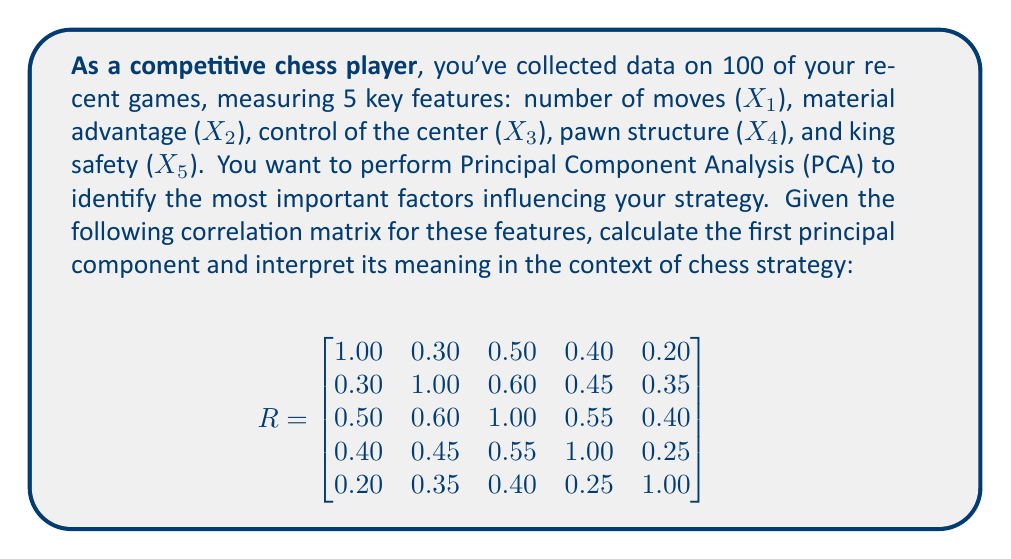Provide a solution to this math problem. To find the first principal component, we need to follow these steps:

1) First, we need to find the eigenvalues and eigenvectors of the correlation matrix R.

2) The largest eigenvalue corresponds to the first principal component, and its associated eigenvector gives the loadings (coefficients) for each feature in the principal component.

3) Using a statistical software or numerical method, we can calculate the eigenvalues and eigenvectors. The eigenvalues (λ) in descending order are:

   λ₁ = 2.6423
   λ₂ = 0.8976
   λ₃ = 0.6234
   λ₄ = 0.4892
   λ₅ = 0.3475

4) The eigenvector corresponding to the largest eigenvalue (λ₁ = 2.6423) is:

   $$v_1 = \begin{bmatrix}
   0.3989 \\
   0.4672 \\
   0.5225 \\
   0.4568 \\
   0.3546
   \end{bmatrix}$$

5) This eigenvector represents the loadings of each feature in the first principal component. We can express the first principal component (PC1) as:

   PC1 = 0.3989X1 + 0.4672X2 + 0.5225X3 + 0.4568X4 + 0.3546X5

6) To interpret this, we look at the magnitude of each coefficient:
   - Control of the center (X3) has the highest coefficient (0.5225)
   - Material advantage (X2) and pawn structure (X4) have the next highest coefficients (0.4672 and 0.4568)
   - Number of moves (X1) and king safety (X5) have slightly lower coefficients (0.3989 and 0.3546)

7) The proportion of variance explained by the first principal component is:

   Proportion = λ₁ / (λ₁ + λ₂ + λ₃ + λ₄ + λ₅) = 2.6423 / 5 = 0.5285 or 52.85%

Interpretation: The first principal component explains 52.85% of the total variance in the data. It represents a weighted average of all five features, with the highest emphasis on control of the center, followed closely by material advantage and pawn structure. This suggests that in your chess games, these three factors are the most important in determining your overall strategy, with control of the center being slightly more influential.
Answer: The first principal component is:

PC1 = 0.3989X1 + 0.4672X2 + 0.5225X3 + 0.4568X4 + 0.3546X5

It explains 52.85% of the total variance and indicates that control of the center, material advantage, and pawn structure are the most influential factors in your chess strategy. 